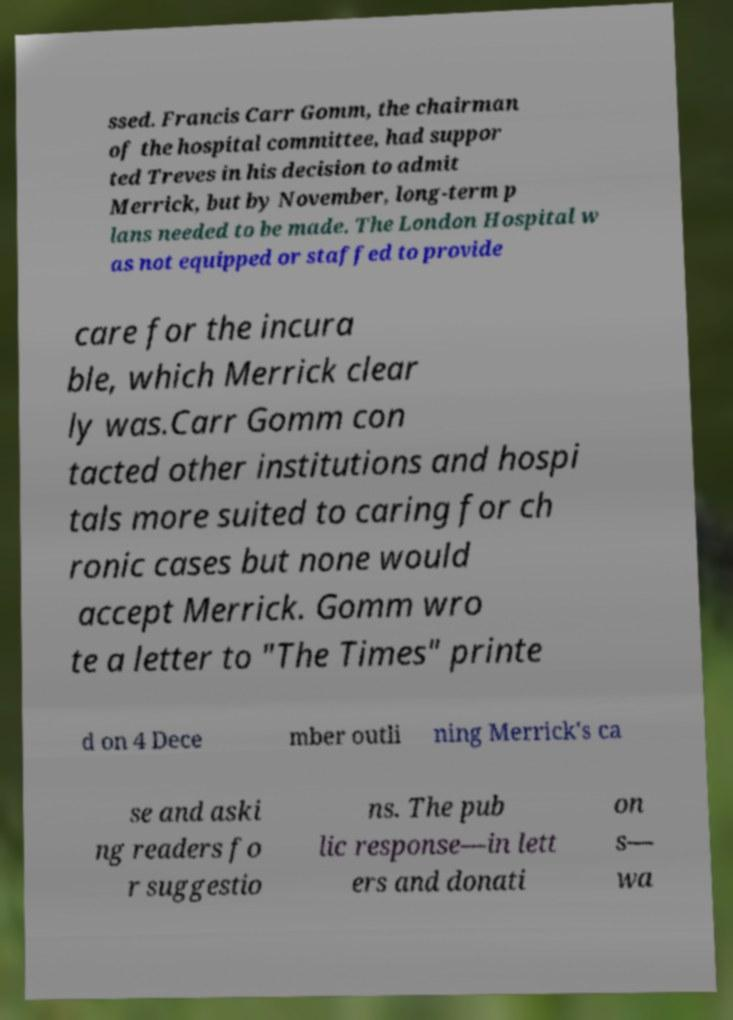Could you extract and type out the text from this image? ssed. Francis Carr Gomm, the chairman of the hospital committee, had suppor ted Treves in his decision to admit Merrick, but by November, long-term p lans needed to be made. The London Hospital w as not equipped or staffed to provide care for the incura ble, which Merrick clear ly was.Carr Gomm con tacted other institutions and hospi tals more suited to caring for ch ronic cases but none would accept Merrick. Gomm wro te a letter to "The Times" printe d on 4 Dece mber outli ning Merrick's ca se and aski ng readers fo r suggestio ns. The pub lic response—in lett ers and donati on s— wa 